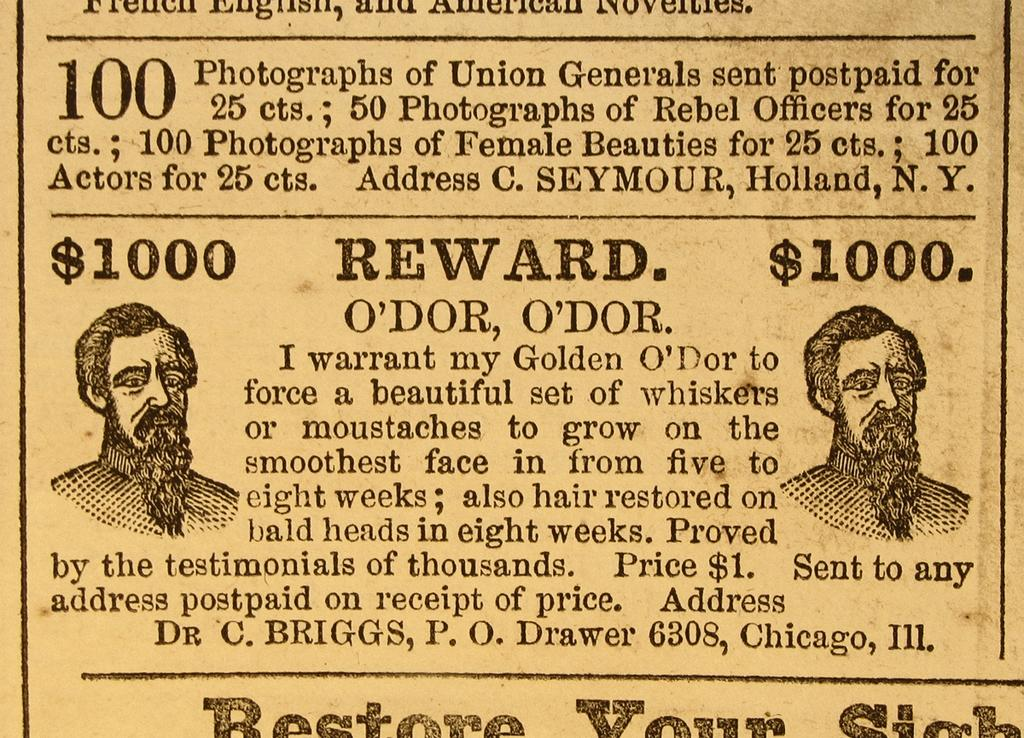What type of paper is featured in the image? There is a yellow color magazine paper in the image. What is written on the magazine paper? A quote is written on the magazine paper. How many eyes can be seen on the magazine paper in the image? There are no eyes visible on the magazine paper in the image. What is the texture of the toe on the magazine paper? There is no toe present on the magazine paper in the image. 